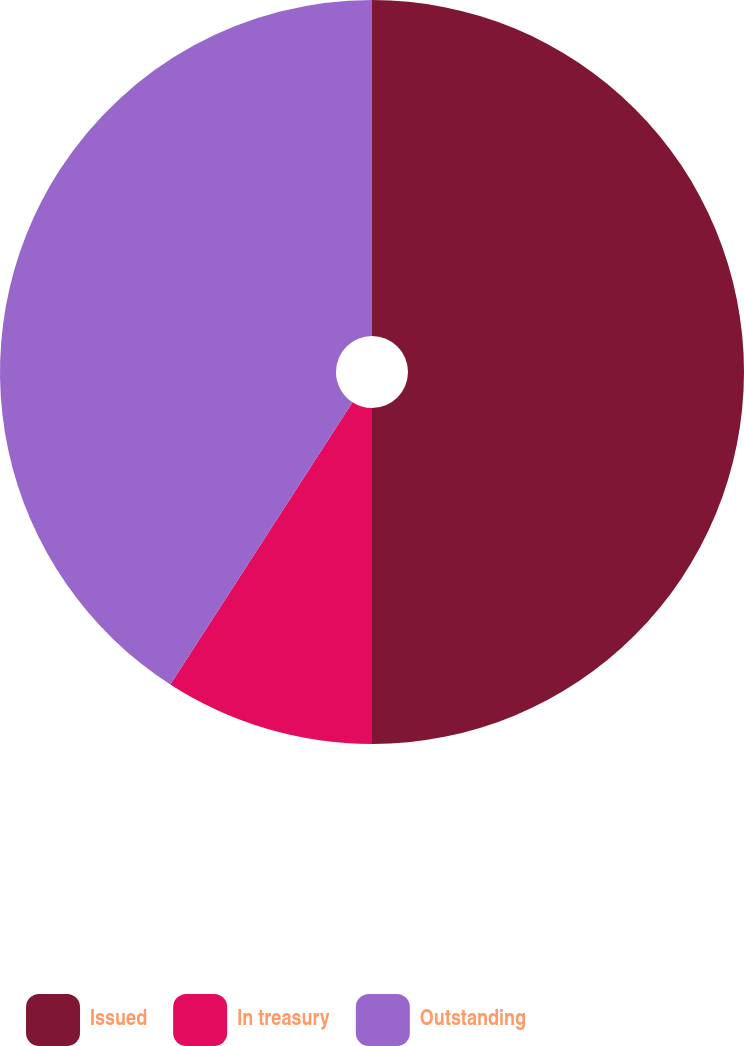Convert chart. <chart><loc_0><loc_0><loc_500><loc_500><pie_chart><fcel>Issued<fcel>In treasury<fcel>Outstanding<nl><fcel>50.0%<fcel>9.12%<fcel>40.88%<nl></chart> 